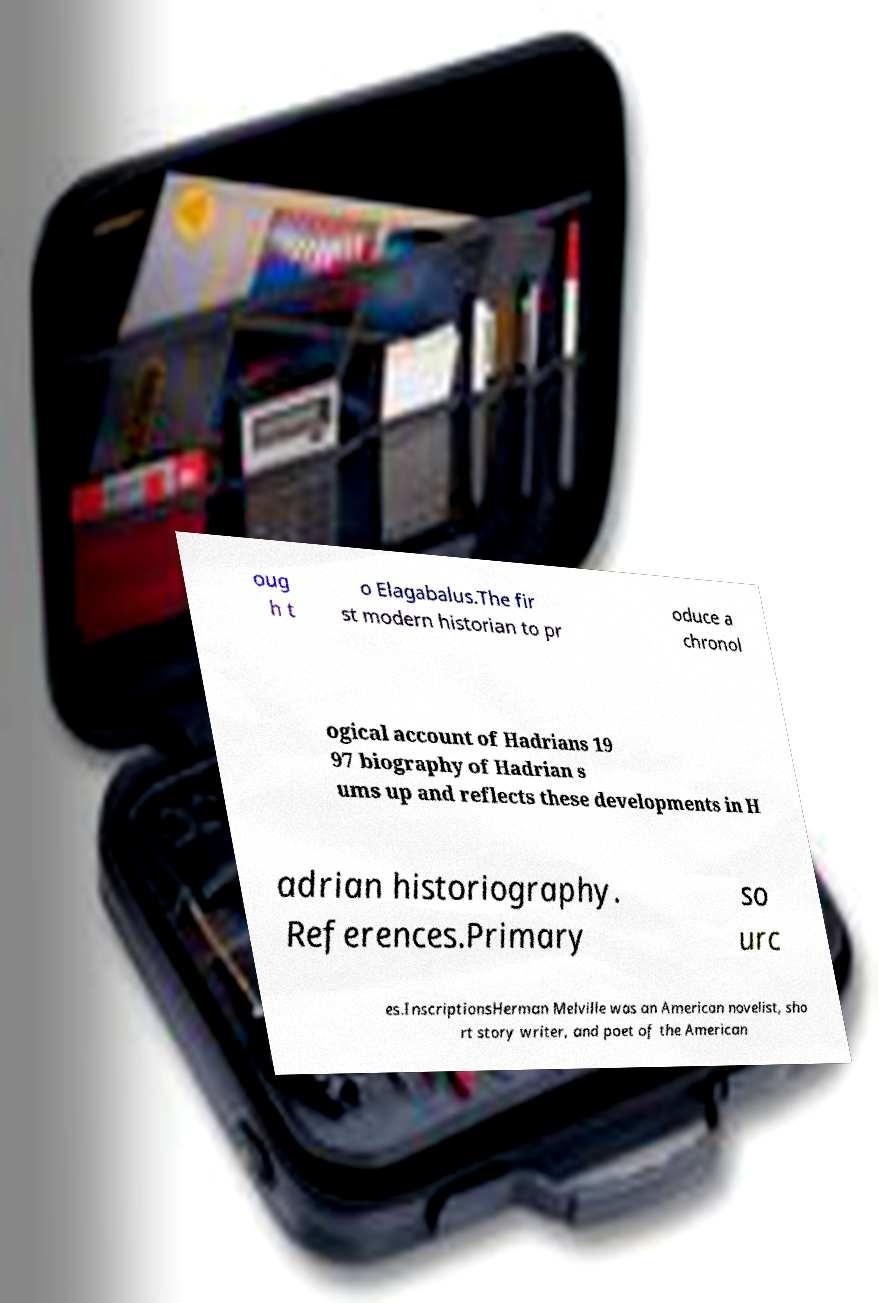Could you extract and type out the text from this image? oug h t o Elagabalus.The fir st modern historian to pr oduce a chronol ogical account of Hadrians 19 97 biography of Hadrian s ums up and reflects these developments in H adrian historiography. References.Primary so urc es.InscriptionsHerman Melville was an American novelist, sho rt story writer, and poet of the American 